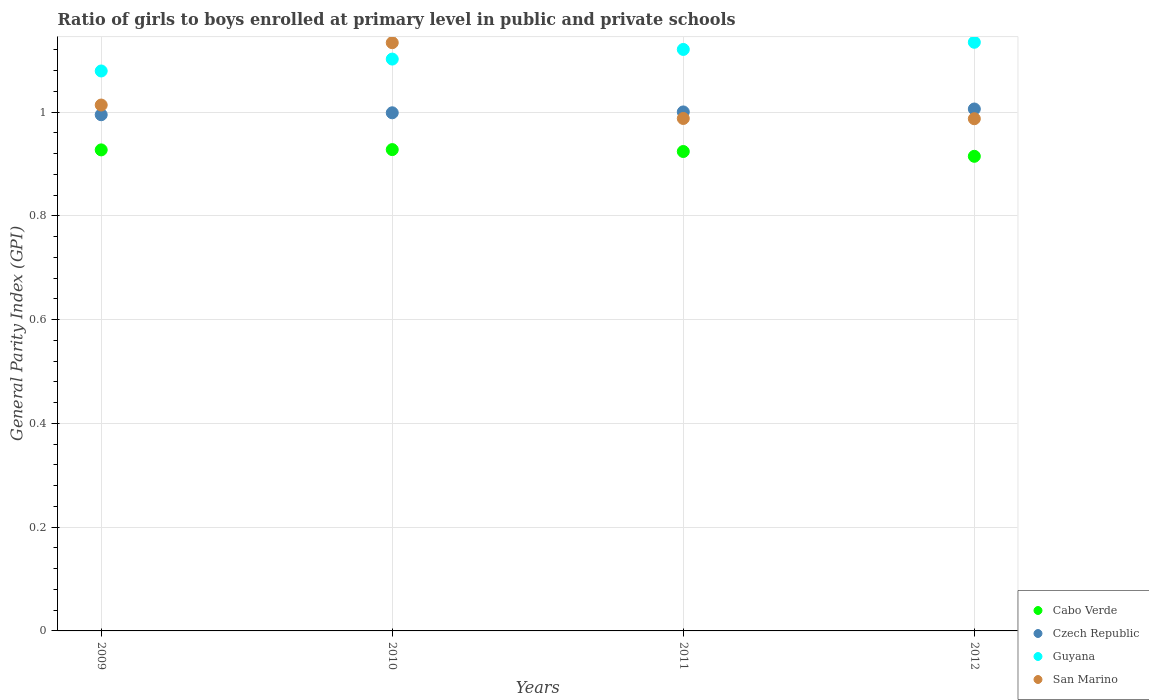Is the number of dotlines equal to the number of legend labels?
Your response must be concise. Yes. What is the general parity index in San Marino in 2012?
Offer a very short reply. 0.99. Across all years, what is the maximum general parity index in Cabo Verde?
Keep it short and to the point. 0.93. Across all years, what is the minimum general parity index in Czech Republic?
Give a very brief answer. 0.99. In which year was the general parity index in Guyana maximum?
Offer a terse response. 2012. What is the total general parity index in Guyana in the graph?
Your answer should be compact. 4.44. What is the difference between the general parity index in Czech Republic in 2009 and that in 2010?
Give a very brief answer. -0. What is the difference between the general parity index in Cabo Verde in 2009 and the general parity index in San Marino in 2010?
Ensure brevity in your answer.  -0.21. What is the average general parity index in San Marino per year?
Your answer should be compact. 1.03. In the year 2011, what is the difference between the general parity index in San Marino and general parity index in Cabo Verde?
Your response must be concise. 0.06. What is the ratio of the general parity index in San Marino in 2009 to that in 2010?
Your answer should be very brief. 0.89. Is the general parity index in Cabo Verde in 2010 less than that in 2011?
Offer a very short reply. No. What is the difference between the highest and the second highest general parity index in Guyana?
Provide a succinct answer. 0.01. What is the difference between the highest and the lowest general parity index in San Marino?
Ensure brevity in your answer.  0.15. In how many years, is the general parity index in Czech Republic greater than the average general parity index in Czech Republic taken over all years?
Provide a succinct answer. 2. Is it the case that in every year, the sum of the general parity index in Guyana and general parity index in San Marino  is greater than the sum of general parity index in Czech Republic and general parity index in Cabo Verde?
Offer a terse response. Yes. Does the general parity index in San Marino monotonically increase over the years?
Provide a short and direct response. No. Is the general parity index in Cabo Verde strictly greater than the general parity index in Czech Republic over the years?
Offer a very short reply. No. Is the general parity index in San Marino strictly less than the general parity index in Czech Republic over the years?
Your answer should be compact. No. How many dotlines are there?
Offer a very short reply. 4. What is the difference between two consecutive major ticks on the Y-axis?
Your answer should be compact. 0.2. Are the values on the major ticks of Y-axis written in scientific E-notation?
Make the answer very short. No. How many legend labels are there?
Your answer should be very brief. 4. What is the title of the graph?
Your answer should be very brief. Ratio of girls to boys enrolled at primary level in public and private schools. What is the label or title of the Y-axis?
Provide a succinct answer. General Parity Index (GPI). What is the General Parity Index (GPI) in Cabo Verde in 2009?
Your response must be concise. 0.93. What is the General Parity Index (GPI) of Czech Republic in 2009?
Offer a very short reply. 0.99. What is the General Parity Index (GPI) of Guyana in 2009?
Your response must be concise. 1.08. What is the General Parity Index (GPI) in San Marino in 2009?
Make the answer very short. 1.01. What is the General Parity Index (GPI) of Cabo Verde in 2010?
Make the answer very short. 0.93. What is the General Parity Index (GPI) of Czech Republic in 2010?
Your answer should be compact. 1. What is the General Parity Index (GPI) in Guyana in 2010?
Give a very brief answer. 1.1. What is the General Parity Index (GPI) in San Marino in 2010?
Your response must be concise. 1.13. What is the General Parity Index (GPI) of Cabo Verde in 2011?
Give a very brief answer. 0.92. What is the General Parity Index (GPI) of Czech Republic in 2011?
Keep it short and to the point. 1. What is the General Parity Index (GPI) in Guyana in 2011?
Your answer should be compact. 1.12. What is the General Parity Index (GPI) of San Marino in 2011?
Your answer should be compact. 0.99. What is the General Parity Index (GPI) of Cabo Verde in 2012?
Offer a very short reply. 0.91. What is the General Parity Index (GPI) of Czech Republic in 2012?
Ensure brevity in your answer.  1.01. What is the General Parity Index (GPI) of Guyana in 2012?
Keep it short and to the point. 1.13. What is the General Parity Index (GPI) of San Marino in 2012?
Offer a terse response. 0.99. Across all years, what is the maximum General Parity Index (GPI) in Cabo Verde?
Provide a succinct answer. 0.93. Across all years, what is the maximum General Parity Index (GPI) in Czech Republic?
Give a very brief answer. 1.01. Across all years, what is the maximum General Parity Index (GPI) in Guyana?
Make the answer very short. 1.13. Across all years, what is the maximum General Parity Index (GPI) in San Marino?
Keep it short and to the point. 1.13. Across all years, what is the minimum General Parity Index (GPI) in Cabo Verde?
Your answer should be compact. 0.91. Across all years, what is the minimum General Parity Index (GPI) of Czech Republic?
Offer a very short reply. 0.99. Across all years, what is the minimum General Parity Index (GPI) in Guyana?
Keep it short and to the point. 1.08. Across all years, what is the minimum General Parity Index (GPI) in San Marino?
Your answer should be compact. 0.99. What is the total General Parity Index (GPI) of Cabo Verde in the graph?
Ensure brevity in your answer.  3.69. What is the total General Parity Index (GPI) in Czech Republic in the graph?
Offer a terse response. 4. What is the total General Parity Index (GPI) in Guyana in the graph?
Provide a succinct answer. 4.44. What is the total General Parity Index (GPI) in San Marino in the graph?
Provide a succinct answer. 4.12. What is the difference between the General Parity Index (GPI) in Cabo Verde in 2009 and that in 2010?
Provide a succinct answer. -0. What is the difference between the General Parity Index (GPI) in Czech Republic in 2009 and that in 2010?
Give a very brief answer. -0. What is the difference between the General Parity Index (GPI) of Guyana in 2009 and that in 2010?
Keep it short and to the point. -0.02. What is the difference between the General Parity Index (GPI) of San Marino in 2009 and that in 2010?
Your answer should be very brief. -0.12. What is the difference between the General Parity Index (GPI) in Cabo Verde in 2009 and that in 2011?
Ensure brevity in your answer.  0. What is the difference between the General Parity Index (GPI) of Czech Republic in 2009 and that in 2011?
Your answer should be compact. -0.01. What is the difference between the General Parity Index (GPI) of Guyana in 2009 and that in 2011?
Your answer should be very brief. -0.04. What is the difference between the General Parity Index (GPI) in San Marino in 2009 and that in 2011?
Your answer should be very brief. 0.03. What is the difference between the General Parity Index (GPI) of Cabo Verde in 2009 and that in 2012?
Give a very brief answer. 0.01. What is the difference between the General Parity Index (GPI) in Czech Republic in 2009 and that in 2012?
Offer a very short reply. -0.01. What is the difference between the General Parity Index (GPI) in Guyana in 2009 and that in 2012?
Provide a succinct answer. -0.06. What is the difference between the General Parity Index (GPI) in San Marino in 2009 and that in 2012?
Give a very brief answer. 0.03. What is the difference between the General Parity Index (GPI) in Cabo Verde in 2010 and that in 2011?
Make the answer very short. 0. What is the difference between the General Parity Index (GPI) of Czech Republic in 2010 and that in 2011?
Offer a very short reply. -0. What is the difference between the General Parity Index (GPI) in Guyana in 2010 and that in 2011?
Your answer should be very brief. -0.02. What is the difference between the General Parity Index (GPI) of San Marino in 2010 and that in 2011?
Give a very brief answer. 0.15. What is the difference between the General Parity Index (GPI) of Cabo Verde in 2010 and that in 2012?
Ensure brevity in your answer.  0.01. What is the difference between the General Parity Index (GPI) of Czech Republic in 2010 and that in 2012?
Provide a short and direct response. -0.01. What is the difference between the General Parity Index (GPI) of Guyana in 2010 and that in 2012?
Ensure brevity in your answer.  -0.03. What is the difference between the General Parity Index (GPI) of San Marino in 2010 and that in 2012?
Ensure brevity in your answer.  0.15. What is the difference between the General Parity Index (GPI) of Cabo Verde in 2011 and that in 2012?
Keep it short and to the point. 0.01. What is the difference between the General Parity Index (GPI) in Czech Republic in 2011 and that in 2012?
Keep it short and to the point. -0.01. What is the difference between the General Parity Index (GPI) of Guyana in 2011 and that in 2012?
Provide a succinct answer. -0.01. What is the difference between the General Parity Index (GPI) in San Marino in 2011 and that in 2012?
Give a very brief answer. 0. What is the difference between the General Parity Index (GPI) of Cabo Verde in 2009 and the General Parity Index (GPI) of Czech Republic in 2010?
Your answer should be very brief. -0.07. What is the difference between the General Parity Index (GPI) in Cabo Verde in 2009 and the General Parity Index (GPI) in Guyana in 2010?
Ensure brevity in your answer.  -0.17. What is the difference between the General Parity Index (GPI) of Cabo Verde in 2009 and the General Parity Index (GPI) of San Marino in 2010?
Provide a short and direct response. -0.21. What is the difference between the General Parity Index (GPI) in Czech Republic in 2009 and the General Parity Index (GPI) in Guyana in 2010?
Provide a succinct answer. -0.11. What is the difference between the General Parity Index (GPI) of Czech Republic in 2009 and the General Parity Index (GPI) of San Marino in 2010?
Make the answer very short. -0.14. What is the difference between the General Parity Index (GPI) in Guyana in 2009 and the General Parity Index (GPI) in San Marino in 2010?
Make the answer very short. -0.05. What is the difference between the General Parity Index (GPI) of Cabo Verde in 2009 and the General Parity Index (GPI) of Czech Republic in 2011?
Provide a short and direct response. -0.07. What is the difference between the General Parity Index (GPI) of Cabo Verde in 2009 and the General Parity Index (GPI) of Guyana in 2011?
Provide a short and direct response. -0.19. What is the difference between the General Parity Index (GPI) of Cabo Verde in 2009 and the General Parity Index (GPI) of San Marino in 2011?
Your answer should be very brief. -0.06. What is the difference between the General Parity Index (GPI) in Czech Republic in 2009 and the General Parity Index (GPI) in Guyana in 2011?
Your answer should be compact. -0.13. What is the difference between the General Parity Index (GPI) of Czech Republic in 2009 and the General Parity Index (GPI) of San Marino in 2011?
Your answer should be very brief. 0.01. What is the difference between the General Parity Index (GPI) of Guyana in 2009 and the General Parity Index (GPI) of San Marino in 2011?
Keep it short and to the point. 0.09. What is the difference between the General Parity Index (GPI) of Cabo Verde in 2009 and the General Parity Index (GPI) of Czech Republic in 2012?
Provide a succinct answer. -0.08. What is the difference between the General Parity Index (GPI) of Cabo Verde in 2009 and the General Parity Index (GPI) of Guyana in 2012?
Your answer should be very brief. -0.21. What is the difference between the General Parity Index (GPI) in Cabo Verde in 2009 and the General Parity Index (GPI) in San Marino in 2012?
Give a very brief answer. -0.06. What is the difference between the General Parity Index (GPI) in Czech Republic in 2009 and the General Parity Index (GPI) in Guyana in 2012?
Your answer should be very brief. -0.14. What is the difference between the General Parity Index (GPI) in Czech Republic in 2009 and the General Parity Index (GPI) in San Marino in 2012?
Your answer should be very brief. 0.01. What is the difference between the General Parity Index (GPI) in Guyana in 2009 and the General Parity Index (GPI) in San Marino in 2012?
Your answer should be compact. 0.09. What is the difference between the General Parity Index (GPI) of Cabo Verde in 2010 and the General Parity Index (GPI) of Czech Republic in 2011?
Offer a very short reply. -0.07. What is the difference between the General Parity Index (GPI) of Cabo Verde in 2010 and the General Parity Index (GPI) of Guyana in 2011?
Keep it short and to the point. -0.19. What is the difference between the General Parity Index (GPI) of Cabo Verde in 2010 and the General Parity Index (GPI) of San Marino in 2011?
Make the answer very short. -0.06. What is the difference between the General Parity Index (GPI) in Czech Republic in 2010 and the General Parity Index (GPI) in Guyana in 2011?
Offer a terse response. -0.12. What is the difference between the General Parity Index (GPI) of Czech Republic in 2010 and the General Parity Index (GPI) of San Marino in 2011?
Give a very brief answer. 0.01. What is the difference between the General Parity Index (GPI) in Guyana in 2010 and the General Parity Index (GPI) in San Marino in 2011?
Offer a very short reply. 0.11. What is the difference between the General Parity Index (GPI) of Cabo Verde in 2010 and the General Parity Index (GPI) of Czech Republic in 2012?
Your response must be concise. -0.08. What is the difference between the General Parity Index (GPI) of Cabo Verde in 2010 and the General Parity Index (GPI) of Guyana in 2012?
Give a very brief answer. -0.21. What is the difference between the General Parity Index (GPI) of Cabo Verde in 2010 and the General Parity Index (GPI) of San Marino in 2012?
Your answer should be very brief. -0.06. What is the difference between the General Parity Index (GPI) in Czech Republic in 2010 and the General Parity Index (GPI) in Guyana in 2012?
Provide a succinct answer. -0.14. What is the difference between the General Parity Index (GPI) of Czech Republic in 2010 and the General Parity Index (GPI) of San Marino in 2012?
Your answer should be very brief. 0.01. What is the difference between the General Parity Index (GPI) of Guyana in 2010 and the General Parity Index (GPI) of San Marino in 2012?
Provide a succinct answer. 0.12. What is the difference between the General Parity Index (GPI) in Cabo Verde in 2011 and the General Parity Index (GPI) in Czech Republic in 2012?
Give a very brief answer. -0.08. What is the difference between the General Parity Index (GPI) of Cabo Verde in 2011 and the General Parity Index (GPI) of Guyana in 2012?
Offer a terse response. -0.21. What is the difference between the General Parity Index (GPI) of Cabo Verde in 2011 and the General Parity Index (GPI) of San Marino in 2012?
Offer a very short reply. -0.06. What is the difference between the General Parity Index (GPI) of Czech Republic in 2011 and the General Parity Index (GPI) of Guyana in 2012?
Your answer should be very brief. -0.13. What is the difference between the General Parity Index (GPI) of Czech Republic in 2011 and the General Parity Index (GPI) of San Marino in 2012?
Your response must be concise. 0.01. What is the difference between the General Parity Index (GPI) of Guyana in 2011 and the General Parity Index (GPI) of San Marino in 2012?
Provide a short and direct response. 0.13. What is the average General Parity Index (GPI) in Cabo Verde per year?
Provide a short and direct response. 0.92. What is the average General Parity Index (GPI) in Guyana per year?
Ensure brevity in your answer.  1.11. What is the average General Parity Index (GPI) in San Marino per year?
Ensure brevity in your answer.  1.03. In the year 2009, what is the difference between the General Parity Index (GPI) of Cabo Verde and General Parity Index (GPI) of Czech Republic?
Your answer should be compact. -0.07. In the year 2009, what is the difference between the General Parity Index (GPI) of Cabo Verde and General Parity Index (GPI) of Guyana?
Provide a short and direct response. -0.15. In the year 2009, what is the difference between the General Parity Index (GPI) in Cabo Verde and General Parity Index (GPI) in San Marino?
Your response must be concise. -0.09. In the year 2009, what is the difference between the General Parity Index (GPI) in Czech Republic and General Parity Index (GPI) in Guyana?
Provide a succinct answer. -0.08. In the year 2009, what is the difference between the General Parity Index (GPI) of Czech Republic and General Parity Index (GPI) of San Marino?
Offer a terse response. -0.02. In the year 2009, what is the difference between the General Parity Index (GPI) in Guyana and General Parity Index (GPI) in San Marino?
Ensure brevity in your answer.  0.07. In the year 2010, what is the difference between the General Parity Index (GPI) of Cabo Verde and General Parity Index (GPI) of Czech Republic?
Ensure brevity in your answer.  -0.07. In the year 2010, what is the difference between the General Parity Index (GPI) in Cabo Verde and General Parity Index (GPI) in Guyana?
Your response must be concise. -0.17. In the year 2010, what is the difference between the General Parity Index (GPI) of Cabo Verde and General Parity Index (GPI) of San Marino?
Your answer should be compact. -0.21. In the year 2010, what is the difference between the General Parity Index (GPI) in Czech Republic and General Parity Index (GPI) in Guyana?
Your response must be concise. -0.1. In the year 2010, what is the difference between the General Parity Index (GPI) in Czech Republic and General Parity Index (GPI) in San Marino?
Your response must be concise. -0.14. In the year 2010, what is the difference between the General Parity Index (GPI) in Guyana and General Parity Index (GPI) in San Marino?
Offer a very short reply. -0.03. In the year 2011, what is the difference between the General Parity Index (GPI) in Cabo Verde and General Parity Index (GPI) in Czech Republic?
Give a very brief answer. -0.08. In the year 2011, what is the difference between the General Parity Index (GPI) in Cabo Verde and General Parity Index (GPI) in Guyana?
Keep it short and to the point. -0.2. In the year 2011, what is the difference between the General Parity Index (GPI) in Cabo Verde and General Parity Index (GPI) in San Marino?
Give a very brief answer. -0.06. In the year 2011, what is the difference between the General Parity Index (GPI) of Czech Republic and General Parity Index (GPI) of Guyana?
Provide a succinct answer. -0.12. In the year 2011, what is the difference between the General Parity Index (GPI) of Czech Republic and General Parity Index (GPI) of San Marino?
Ensure brevity in your answer.  0.01. In the year 2011, what is the difference between the General Parity Index (GPI) of Guyana and General Parity Index (GPI) of San Marino?
Give a very brief answer. 0.13. In the year 2012, what is the difference between the General Parity Index (GPI) of Cabo Verde and General Parity Index (GPI) of Czech Republic?
Keep it short and to the point. -0.09. In the year 2012, what is the difference between the General Parity Index (GPI) of Cabo Verde and General Parity Index (GPI) of Guyana?
Offer a terse response. -0.22. In the year 2012, what is the difference between the General Parity Index (GPI) in Cabo Verde and General Parity Index (GPI) in San Marino?
Offer a very short reply. -0.07. In the year 2012, what is the difference between the General Parity Index (GPI) of Czech Republic and General Parity Index (GPI) of Guyana?
Provide a succinct answer. -0.13. In the year 2012, what is the difference between the General Parity Index (GPI) in Czech Republic and General Parity Index (GPI) in San Marino?
Offer a very short reply. 0.02. In the year 2012, what is the difference between the General Parity Index (GPI) of Guyana and General Parity Index (GPI) of San Marino?
Give a very brief answer. 0.15. What is the ratio of the General Parity Index (GPI) of Guyana in 2009 to that in 2010?
Provide a short and direct response. 0.98. What is the ratio of the General Parity Index (GPI) of San Marino in 2009 to that in 2010?
Offer a very short reply. 0.89. What is the ratio of the General Parity Index (GPI) of Cabo Verde in 2009 to that in 2011?
Your answer should be very brief. 1. What is the ratio of the General Parity Index (GPI) of Czech Republic in 2009 to that in 2011?
Keep it short and to the point. 0.99. What is the ratio of the General Parity Index (GPI) in San Marino in 2009 to that in 2011?
Ensure brevity in your answer.  1.03. What is the ratio of the General Parity Index (GPI) of Cabo Verde in 2009 to that in 2012?
Offer a very short reply. 1.01. What is the ratio of the General Parity Index (GPI) in Guyana in 2009 to that in 2012?
Ensure brevity in your answer.  0.95. What is the ratio of the General Parity Index (GPI) of San Marino in 2009 to that in 2012?
Your response must be concise. 1.03. What is the ratio of the General Parity Index (GPI) of Czech Republic in 2010 to that in 2011?
Ensure brevity in your answer.  1. What is the ratio of the General Parity Index (GPI) of Guyana in 2010 to that in 2011?
Your response must be concise. 0.98. What is the ratio of the General Parity Index (GPI) of San Marino in 2010 to that in 2011?
Offer a terse response. 1.15. What is the ratio of the General Parity Index (GPI) in Cabo Verde in 2010 to that in 2012?
Your answer should be very brief. 1.01. What is the ratio of the General Parity Index (GPI) in Czech Republic in 2010 to that in 2012?
Ensure brevity in your answer.  0.99. What is the ratio of the General Parity Index (GPI) in Guyana in 2010 to that in 2012?
Your response must be concise. 0.97. What is the ratio of the General Parity Index (GPI) of San Marino in 2010 to that in 2012?
Your response must be concise. 1.15. What is the ratio of the General Parity Index (GPI) of Cabo Verde in 2011 to that in 2012?
Offer a very short reply. 1.01. What is the ratio of the General Parity Index (GPI) in Czech Republic in 2011 to that in 2012?
Provide a succinct answer. 0.99. What is the ratio of the General Parity Index (GPI) in San Marino in 2011 to that in 2012?
Ensure brevity in your answer.  1. What is the difference between the highest and the second highest General Parity Index (GPI) of Czech Republic?
Provide a short and direct response. 0.01. What is the difference between the highest and the second highest General Parity Index (GPI) of Guyana?
Offer a very short reply. 0.01. What is the difference between the highest and the second highest General Parity Index (GPI) in San Marino?
Your answer should be compact. 0.12. What is the difference between the highest and the lowest General Parity Index (GPI) of Cabo Verde?
Give a very brief answer. 0.01. What is the difference between the highest and the lowest General Parity Index (GPI) of Czech Republic?
Make the answer very short. 0.01. What is the difference between the highest and the lowest General Parity Index (GPI) of Guyana?
Ensure brevity in your answer.  0.06. What is the difference between the highest and the lowest General Parity Index (GPI) of San Marino?
Your answer should be compact. 0.15. 